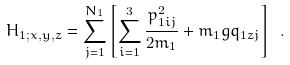<formula> <loc_0><loc_0><loc_500><loc_500>H _ { 1 ; x , y , z } = \sum _ { j = 1 } ^ { N _ { 1 } } \left [ \sum _ { i = 1 } ^ { 3 } \frac { p _ { 1 i j } ^ { 2 } } { 2 m _ { 1 } } + m _ { 1 } g q _ { 1 z j } \right ] \ .</formula> 